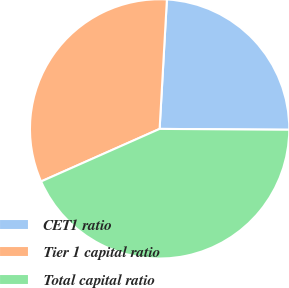Convert chart to OTSL. <chart><loc_0><loc_0><loc_500><loc_500><pie_chart><fcel>CET1 ratio<fcel>Tier 1 capital ratio<fcel>Total capital ratio<nl><fcel>24.21%<fcel>32.54%<fcel>43.25%<nl></chart> 